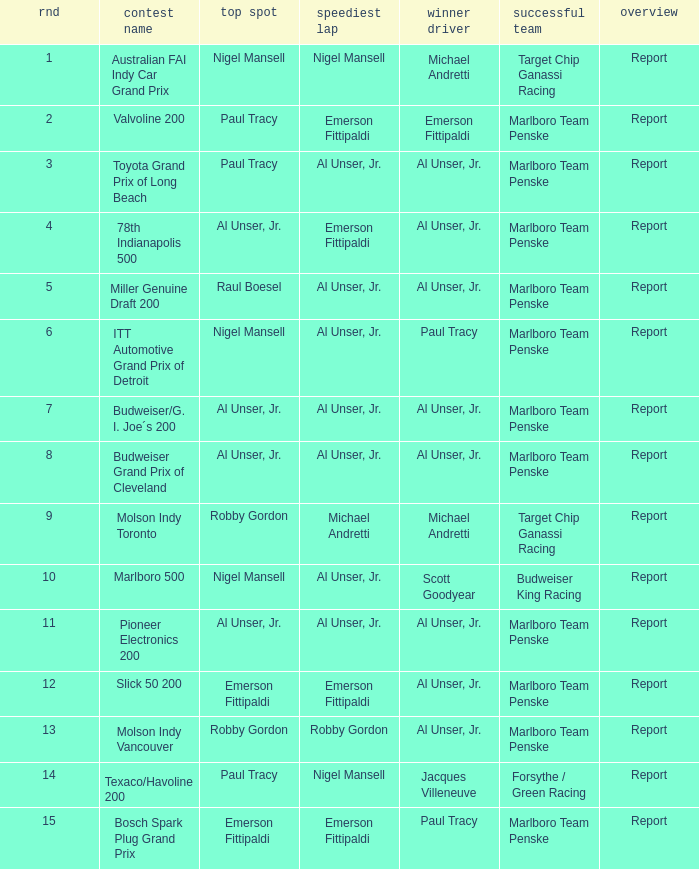Would you be able to parse every entry in this table? {'header': ['rnd', 'contest name', 'top spot', 'speediest lap', 'winner driver', 'successful team', 'overview'], 'rows': [['1', 'Australian FAI Indy Car Grand Prix', 'Nigel Mansell', 'Nigel Mansell', 'Michael Andretti', 'Target Chip Ganassi Racing', 'Report'], ['2', 'Valvoline 200', 'Paul Tracy', 'Emerson Fittipaldi', 'Emerson Fittipaldi', 'Marlboro Team Penske', 'Report'], ['3', 'Toyota Grand Prix of Long Beach', 'Paul Tracy', 'Al Unser, Jr.', 'Al Unser, Jr.', 'Marlboro Team Penske', 'Report'], ['4', '78th Indianapolis 500', 'Al Unser, Jr.', 'Emerson Fittipaldi', 'Al Unser, Jr.', 'Marlboro Team Penske', 'Report'], ['5', 'Miller Genuine Draft 200', 'Raul Boesel', 'Al Unser, Jr.', 'Al Unser, Jr.', 'Marlboro Team Penske', 'Report'], ['6', 'ITT Automotive Grand Prix of Detroit', 'Nigel Mansell', 'Al Unser, Jr.', 'Paul Tracy', 'Marlboro Team Penske', 'Report'], ['7', 'Budweiser/G. I. Joe´s 200', 'Al Unser, Jr.', 'Al Unser, Jr.', 'Al Unser, Jr.', 'Marlboro Team Penske', 'Report'], ['8', 'Budweiser Grand Prix of Cleveland', 'Al Unser, Jr.', 'Al Unser, Jr.', 'Al Unser, Jr.', 'Marlboro Team Penske', 'Report'], ['9', 'Molson Indy Toronto', 'Robby Gordon', 'Michael Andretti', 'Michael Andretti', 'Target Chip Ganassi Racing', 'Report'], ['10', 'Marlboro 500', 'Nigel Mansell', 'Al Unser, Jr.', 'Scott Goodyear', 'Budweiser King Racing', 'Report'], ['11', 'Pioneer Electronics 200', 'Al Unser, Jr.', 'Al Unser, Jr.', 'Al Unser, Jr.', 'Marlboro Team Penske', 'Report'], ['12', 'Slick 50 200', 'Emerson Fittipaldi', 'Emerson Fittipaldi', 'Al Unser, Jr.', 'Marlboro Team Penske', 'Report'], ['13', 'Molson Indy Vancouver', 'Robby Gordon', 'Robby Gordon', 'Al Unser, Jr.', 'Marlboro Team Penske', 'Report'], ['14', 'Texaco/Havoline 200', 'Paul Tracy', 'Nigel Mansell', 'Jacques Villeneuve', 'Forsythe / Green Racing', 'Report'], ['15', 'Bosch Spark Plug Grand Prix', 'Emerson Fittipaldi', 'Emerson Fittipaldi', 'Paul Tracy', 'Marlboro Team Penske', 'Report']]} Who did the fastest lap in the race won by Paul Tracy, with Emerson Fittipaldi at the pole position? Emerson Fittipaldi. 